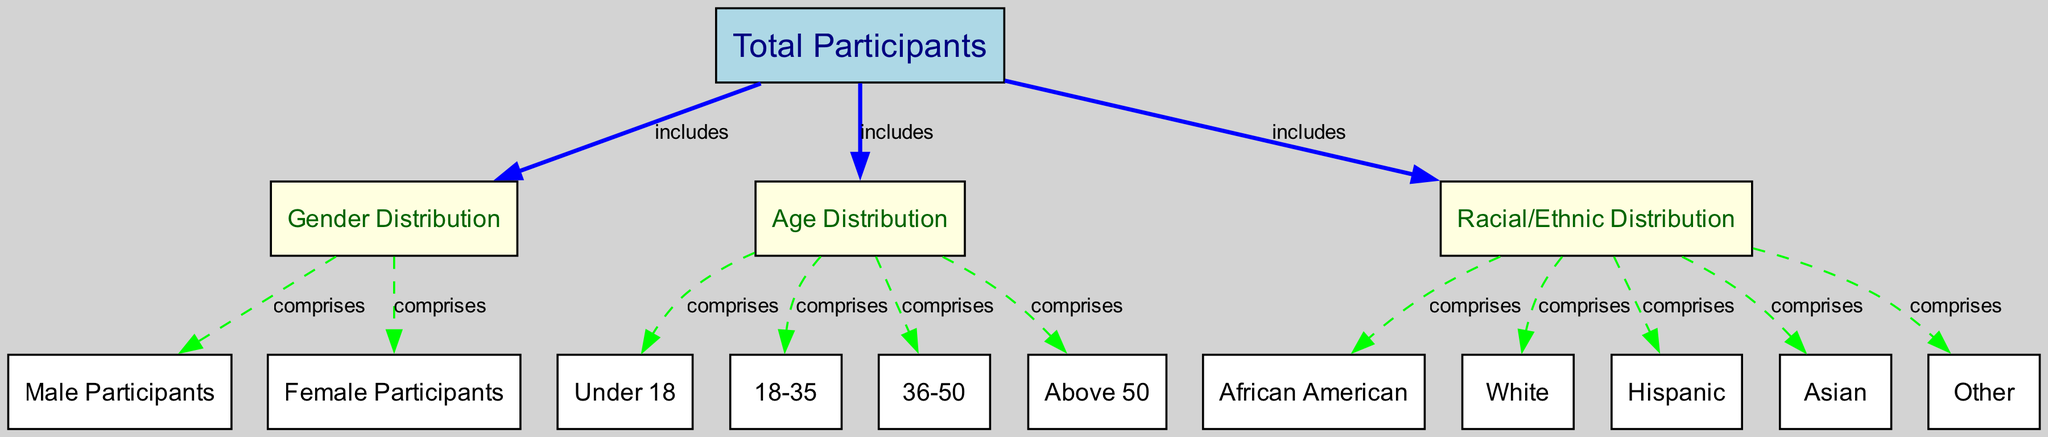What is the total number of participants? The diagram starts with the "Total Participants" node, which represents the overall number of people involved. This value is directly illustrated in that node.
Answer: Total Participants How many male participants are there? To find the number of male participants, we look at the "Male Participants" node, which is linked to the "Gender Distribution" node that falls under the "Total Participants" node. The value in this node is indicative of the count of male participants.
Answer: Male Participants What proportion of participants are female? The "Female Participants" node is directly associated with the "Gender Distribution" node, showing the number of female participants. To get the proportion, one would compare the value in this node to the value in the "Total Participants" node.
Answer: Female Participants How many participants are aged under 18? The "Under 18" node is part of the "Age Distribution" section, which breaks down the overall number of participants by different age groups. Looking at the value in this node gives the count of participants younger than 18.
Answer: Under 18 Which racial/ethnic group has the highest representation? This requires analyzing the "Racial/Ethnic Distribution" section of the diagram. The groups represented include "African American," "White," "Hispanic," "Asian," and "Other." By comparing the values in these nodes, the group with the highest count can be identified.
Answer: Highest group representation Which two categories show the strongest correlation in terms of participation? To identify correlation, we examine the edges connecting the "Total Participants" node to the "Gender Distribution," "Age Distribution," and "Racial/Ethnic Distribution" nodes. One would look for patterns in values between these categories.
Answer: Strongest correlation How many age categories are represented in the diagram? The "Age Distribution" node includes branches for four specific age categories: "Under 18," "18-35," "36-50," and "Above 50." Counting these categories gives the number of age segments represented in the outreach programs.
Answer: Four age categories What is the total number of racial/ethnic groups shown in the diagram? The "Racial/Ethnic Distribution" node comprises five specific groups: "African American," "White," "Hispanic," "Asian," and "Other." The sum of these groups indicates the total number of racial/ethnic categories included in the program.
Answer: Five racial/ethnic groups 